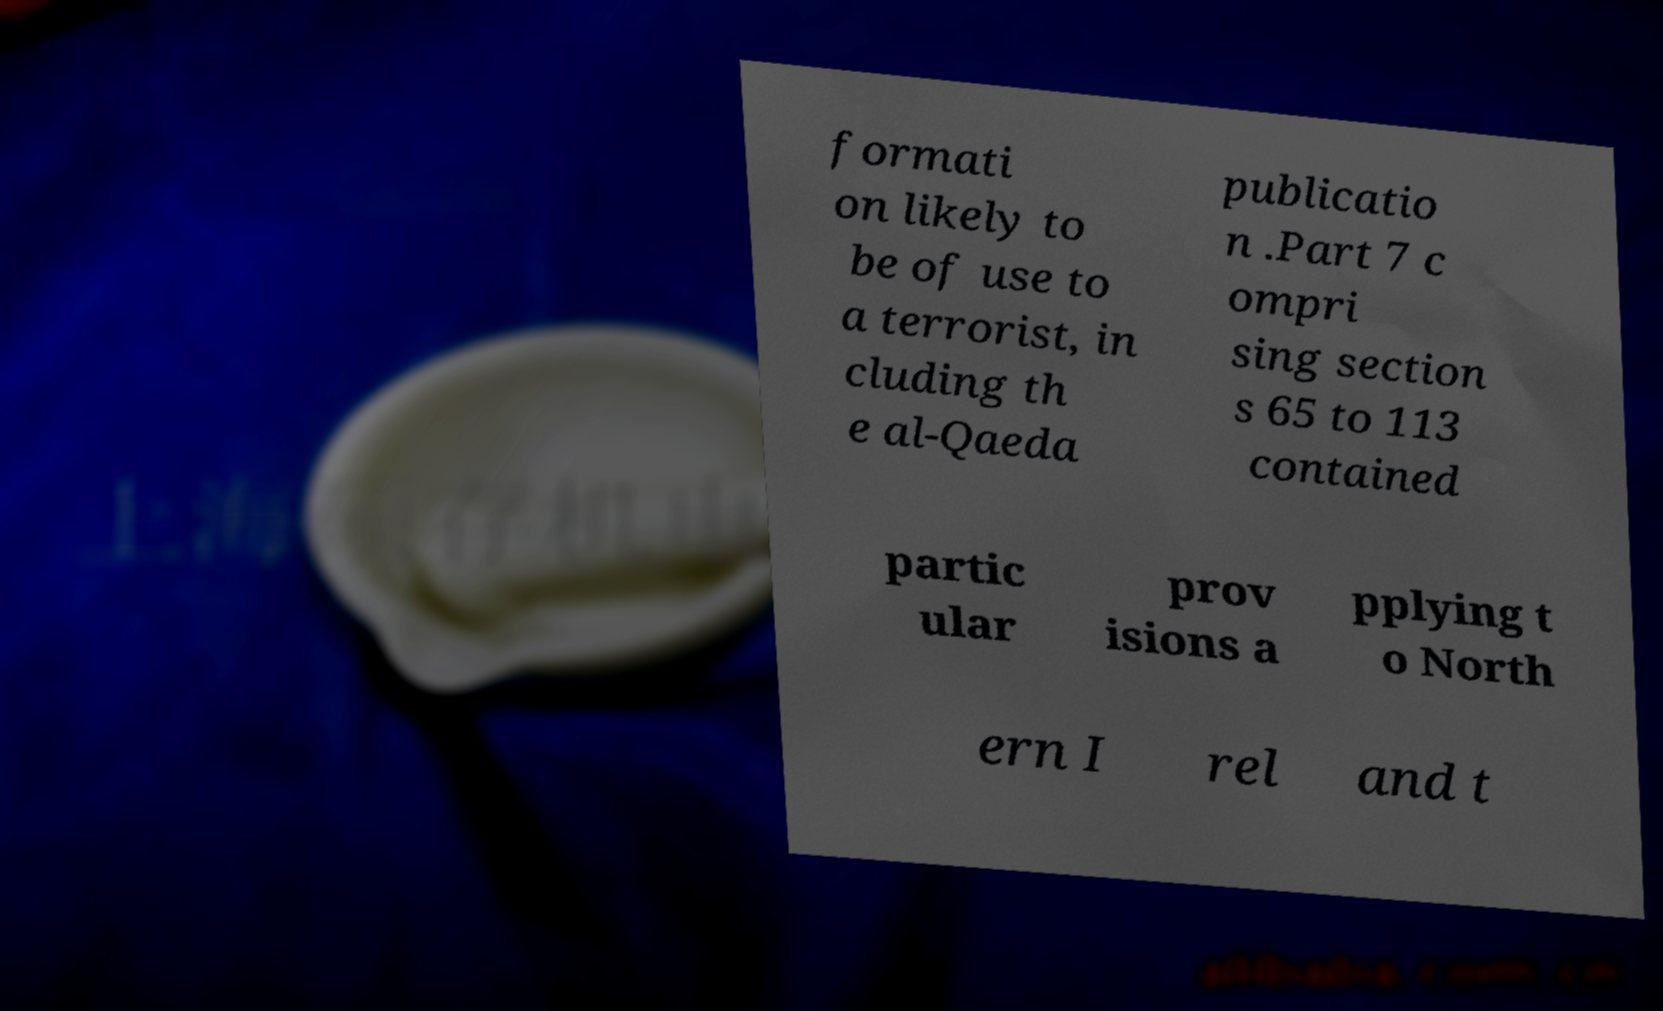What messages or text are displayed in this image? I need them in a readable, typed format. formati on likely to be of use to a terrorist, in cluding th e al-Qaeda publicatio n .Part 7 c ompri sing section s 65 to 113 contained partic ular prov isions a pplying t o North ern I rel and t 